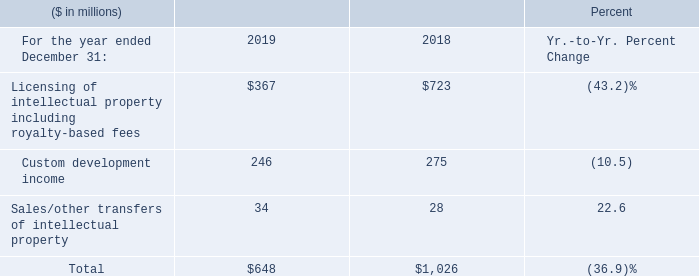Intellectual Property and Custom Development Income
Licensing of intellectual property including royalty-based fees decreased 49.2 percent in 2019 compared to 2018. This was primarily due to a decline in new partnership agreements compared to the prior year. The timing and amount of licensing, sales or other transfers of IP may vary significantly from period to period depending upon the timing of licensing agreements, economic conditions, industry consolidation and the timing of new patents and know-how development.
What was the decrease in Licensing of intellectual property? 49.2 percent. What caused the decrease in Licensing of intellectual property? This was primarily due to a decline in new partnership agreements compared to the prior year. the timing and amount of licensing, sales or other transfers of ip may vary significantly from period to period depending upon the timing of licensing agreements, economic conditions, industry consolidation and the timing of new patents and know-how development. What was the Custom development income in 2018?
Answer scale should be: million. 275. What was the Licensing of intellectual property including royalty-based fees average?
Answer scale should be: million. (367 + 723) / 2
Answer: 545. What was the increase / (decrease) in the Custom development income from 2018 to 2019?
Answer scale should be: million. 246 - 275
Answer: -29. What was the increase / (decrease) in the Sales/other transfers of intellectual property from 2018 to 2019?
Answer scale should be: million. 34 - 28
Answer: 6. 